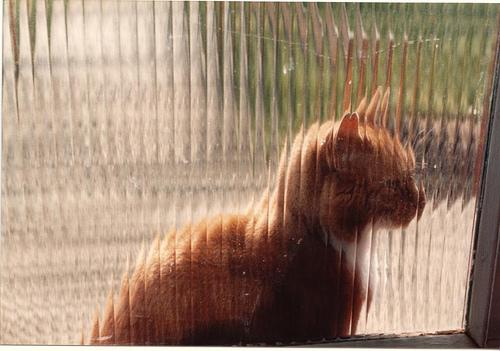Elaborate on the condition of the window and any notable patterns or textures. The window is frosted and textured with lines, and has a ribbed pattern. It also shows scratches, dirt, and brown stains on the edges. What colors are present in the cat's fur, and where are they specifically found? The cat has orange fur on its body and white fur under its chin and on the front of its body. What type of outdoor environment can be seen outside the window? There is green grass, trees, and possibly a sidewalk next to the yard being displayed outside the window. How many objects or subjects can be mentioned in the image description, and what are they? There are four primary subjects: the cat, the window, the outdoor environment, and the cat's reflection in the window. Explain the cat's posture and direction it is looking towards. The cat is sitting with its body against the window, looking to the left, and facing the door. What is the primary focus of the image, and what is its state? The primary focus of the image is an orange cat sitting behind a window, staring ahead and appearing to be standing still. In a detailed manner, describe the cat's fur and facial features. The cat has orange and white fur, with a white patch under its chin and ruffled fur on the side of its head. It has green eyes, pointed ears, and whiskers on its face. What type of window is the cat behind, and how can it be characterized? The cat is behind a frosted window with a grey frame and a ribbed pattern, showing scratches, dirt, and a brown trim on the side. What reflections from the window can be seen, and what do they depict? Reflections from the glass show the cat's ears and a part of the environment outside the window. Detect any anomalies present in the window glass. Scratch, dirt, and ribbed pattern in the window glass. Determine the cat's eye color. The cat's eyes are green. Is the cat looking to the left or the right? The cat is looking to the left. What is the color of the window frame? The window frame is grey. Calculate the area of the grass in the image. Width: 290 pixels, Height: 290 pixels, Area: 84100 pixels. Are there any reflections visible in the window? Yes, a reflection of the cat's ears is visible in the window. List three colors that can be seen in the image. Orange, white, and green. Identify the interaction between the cat and the window. The cat is sitting behind the window and looking through it. Describe the main subject of the image.  A cat sitting behind a window with orange and white fur. Describe the background beyond the window in the image. The background has a white color behind the cat, green grass, or trees. How would you describe the cat's ears? Pointed up, with a reflection from the glass showing them. What can be seen beyond the cat outside the window? Green grass, trees, and possibly a sidewalk. Is there any fur pattern on the cat's face? Yes, there are ruffled fur on the side of the cat's head and whiskers on the cat's face. Identify the surface where the cat is sitting. The cat is sitting behind a window. Identify the material of the window's edge. The window's edge has a brown trim, and there is a brown stain bleeding onto it. Identify the texture of the window. The window is textured with lines, and it is frosted. What position is the cat in? The cat is sitting still and facing the door. Evaluate the image quality based on clarity, resolution, and object details. The image has good clarity, high resolution, and clear object details. 